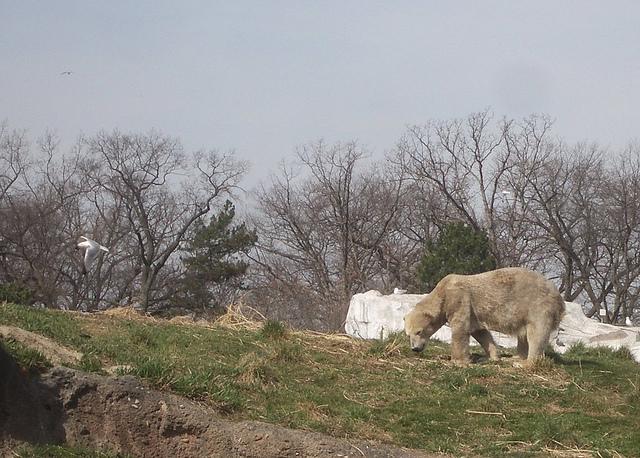What type of animals are in the picture?
Keep it brief. Bear. What is the color of the bears?
Write a very short answer. White. Is the animal standing on a hillside?
Give a very brief answer. Yes. What is the bear standing on?
Answer briefly. Grass. Is the animal standing?
Quick response, please. Yes. How many polar bears are in the photo?
Write a very short answer. 1. Is the bear climbing a mountain?
Concise answer only. No. What's the best appearing to be doing?
Short answer required. Eating. What is the white object behind the bear?
Be succinct. Rock. What kind of bear is in this picture?
Short answer required. Polar. What kind of bear is this?
Keep it brief. Polar bear. 